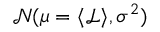<formula> <loc_0><loc_0><loc_500><loc_500>\mathcal { N } ( \mu = \langle \mathcal { L } \rangle , \sigma ^ { 2 } )</formula> 